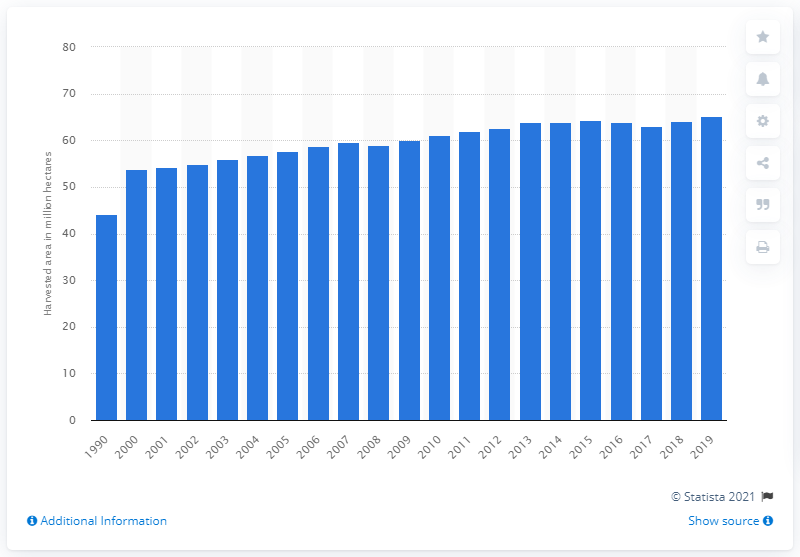Highlight a few significant elements in this photo. In 2019, the global area of fresh fruit harvested was approximately 64.4 million hectares. 